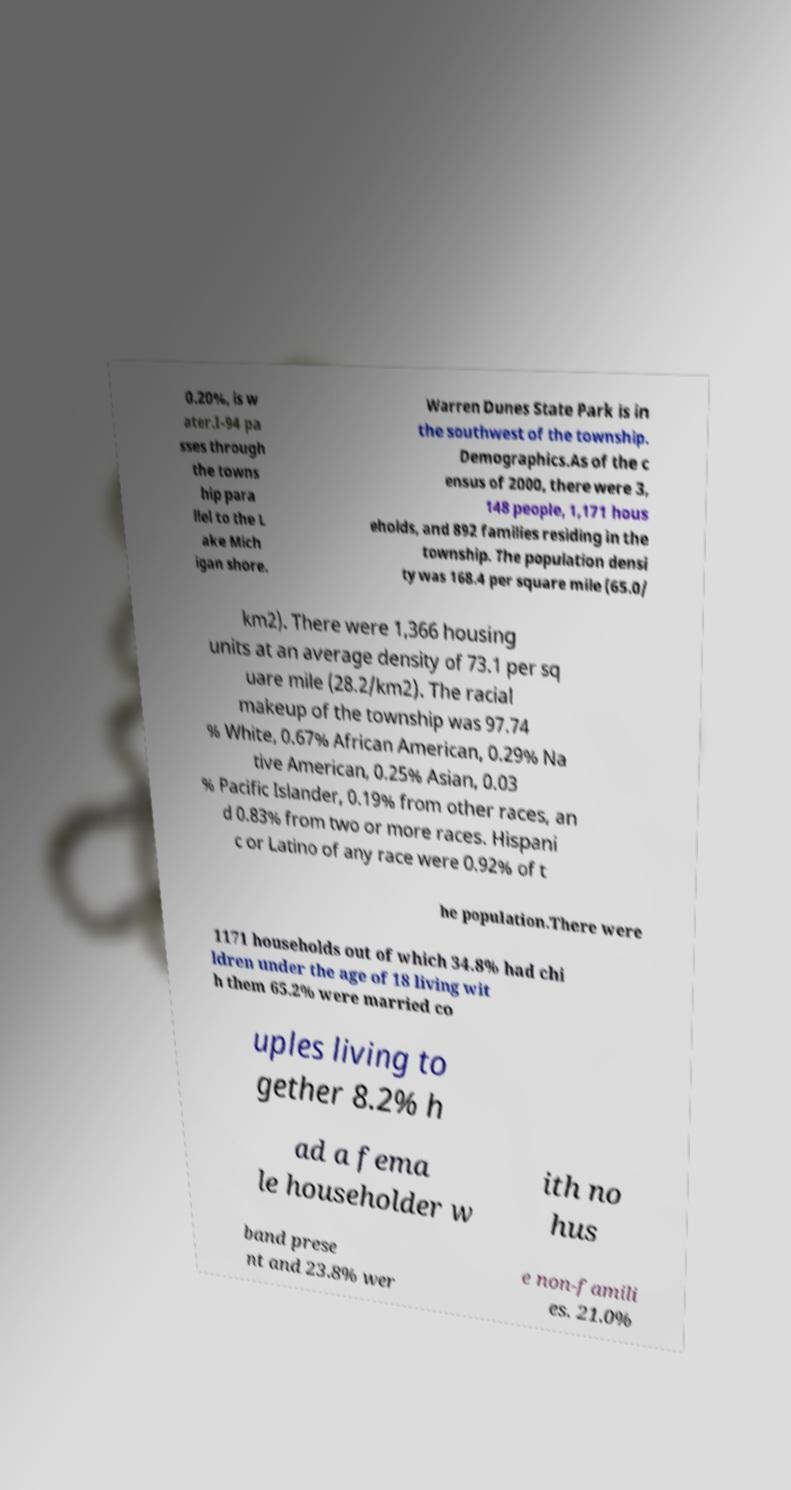Can you read and provide the text displayed in the image?This photo seems to have some interesting text. Can you extract and type it out for me? 0.20%, is w ater.I-94 pa sses through the towns hip para llel to the L ake Mich igan shore. Warren Dunes State Park is in the southwest of the township. Demographics.As of the c ensus of 2000, there were 3, 148 people, 1,171 hous eholds, and 892 families residing in the township. The population densi ty was 168.4 per square mile (65.0/ km2). There were 1,366 housing units at an average density of 73.1 per sq uare mile (28.2/km2). The racial makeup of the township was 97.74 % White, 0.67% African American, 0.29% Na tive American, 0.25% Asian, 0.03 % Pacific Islander, 0.19% from other races, an d 0.83% from two or more races. Hispani c or Latino of any race were 0.92% of t he population.There were 1171 households out of which 34.8% had chi ldren under the age of 18 living wit h them 65.2% were married co uples living to gether 8.2% h ad a fema le householder w ith no hus band prese nt and 23.8% wer e non-famili es. 21.0% 